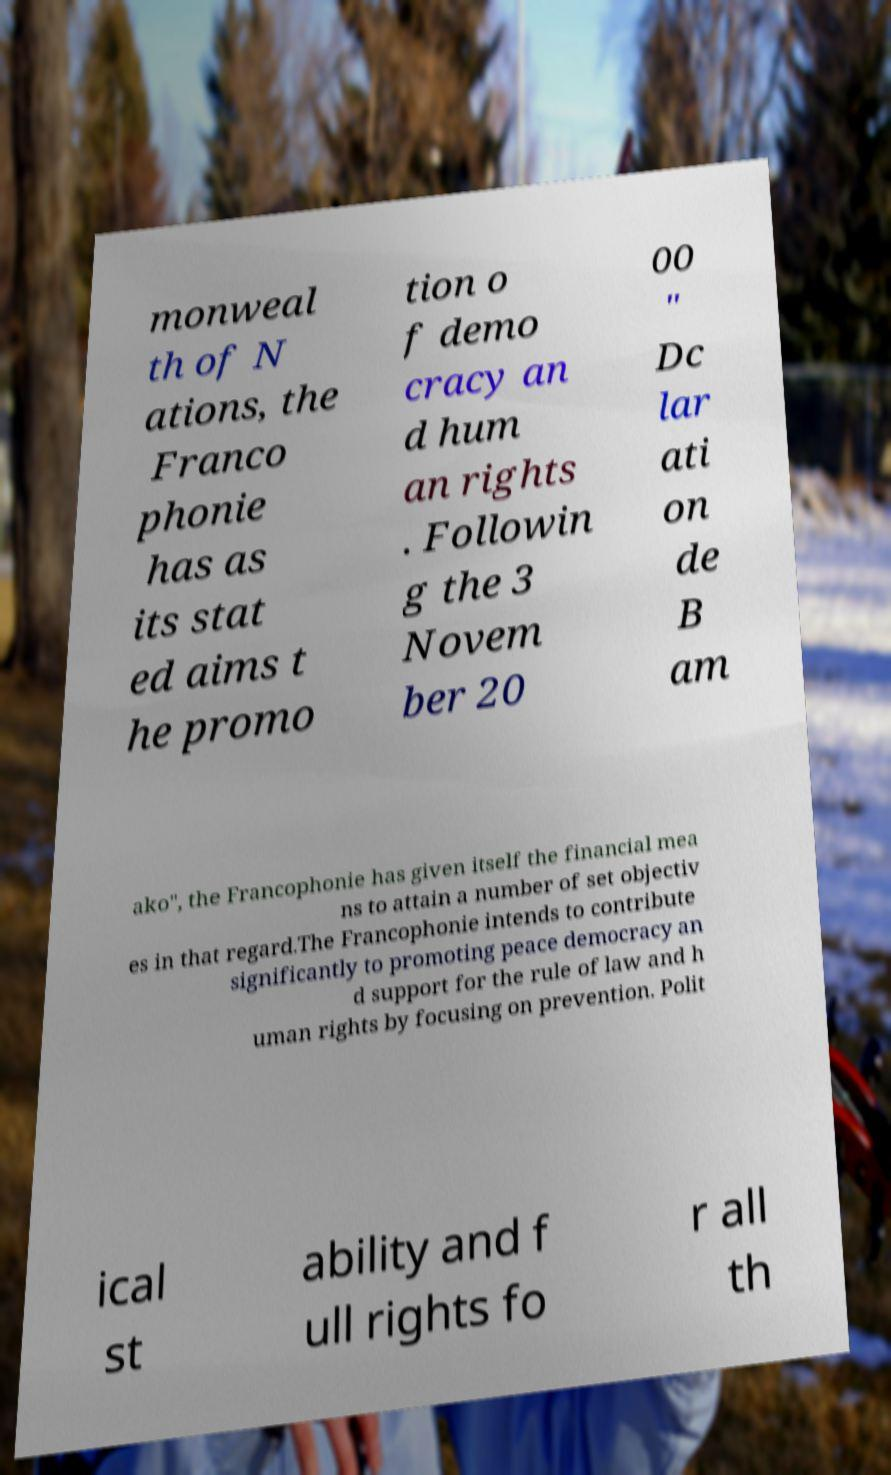Could you assist in decoding the text presented in this image and type it out clearly? monweal th of N ations, the Franco phonie has as its stat ed aims t he promo tion o f demo cracy an d hum an rights . Followin g the 3 Novem ber 20 00 " Dc lar ati on de B am ako", the Francophonie has given itself the financial mea ns to attain a number of set objectiv es in that regard.The Francophonie intends to contribute significantly to promoting peace democracy an d support for the rule of law and h uman rights by focusing on prevention. Polit ical st ability and f ull rights fo r all th 